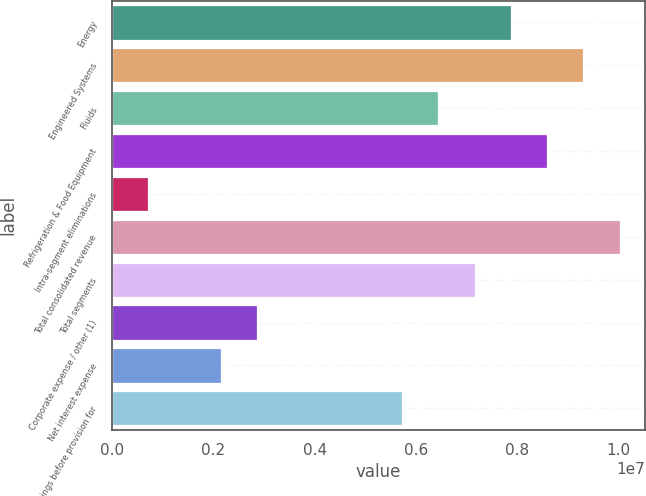Convert chart. <chart><loc_0><loc_0><loc_500><loc_500><bar_chart><fcel>Energy<fcel>Engineered Systems<fcel>Fluids<fcel>Refrigeration & Food Equipment<fcel>Intra-segment eliminations<fcel>Total consolidated revenue<fcel>Total segments<fcel>Corporate expense / other (1)<fcel>Net interest expense<fcel>Earnings before provision for<nl><fcel>7.8706e+06<fcel>9.30162e+06<fcel>6.43959e+06<fcel>8.58611e+06<fcel>715526<fcel>1.00171e+07<fcel>7.1551e+06<fcel>2.86205e+06<fcel>2.14654e+06<fcel>5.72408e+06<nl></chart> 